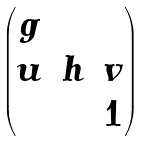Convert formula to latex. <formula><loc_0><loc_0><loc_500><loc_500>\begin{pmatrix} g & & \\ u & h & v \\ & & 1 \end{pmatrix}</formula> 